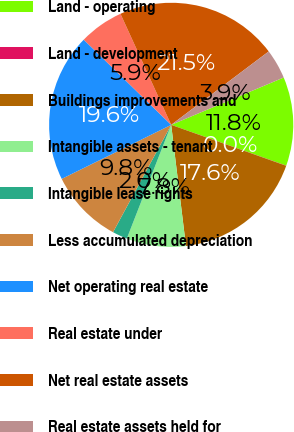<chart> <loc_0><loc_0><loc_500><loc_500><pie_chart><fcel>Land - operating<fcel>Land - development<fcel>Buildings improvements and<fcel>Intangible assets - tenant<fcel>Intangible lease rights<fcel>Less accumulated depreciation<fcel>Net operating real estate<fcel>Real estate under<fcel>Net real estate assets<fcel>Real estate assets held for<nl><fcel>11.76%<fcel>0.02%<fcel>17.63%<fcel>7.85%<fcel>1.98%<fcel>9.8%<fcel>19.59%<fcel>5.89%<fcel>21.55%<fcel>3.93%<nl></chart> 